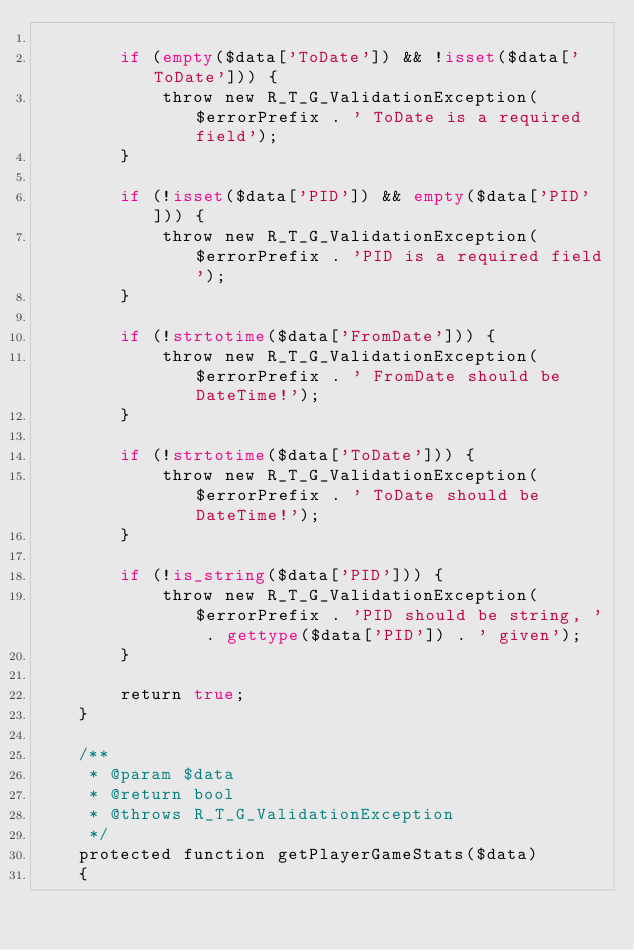<code> <loc_0><loc_0><loc_500><loc_500><_PHP_>
        if (empty($data['ToDate']) && !isset($data['ToDate'])) {
            throw new R_T_G_ValidationException($errorPrefix . ' ToDate is a required field');
        }

        if (!isset($data['PID']) && empty($data['PID'])) {
            throw new R_T_G_ValidationException($errorPrefix . 'PID is a required field');
        }

        if (!strtotime($data['FromDate'])) {
            throw new R_T_G_ValidationException($errorPrefix . ' FromDate should be DateTime!');
        }

        if (!strtotime($data['ToDate'])) {
            throw new R_T_G_ValidationException($errorPrefix . ' ToDate should be DateTime!');
        }

        if (!is_string($data['PID'])) {
            throw new R_T_G_ValidationException($errorPrefix . 'PID should be string, ' . gettype($data['PID']) . ' given');
        }

        return true;
    }

    /**
     * @param $data
     * @return bool
     * @throws R_T_G_ValidationException
     */
    protected function getPlayerGameStats($data)
    {</code> 